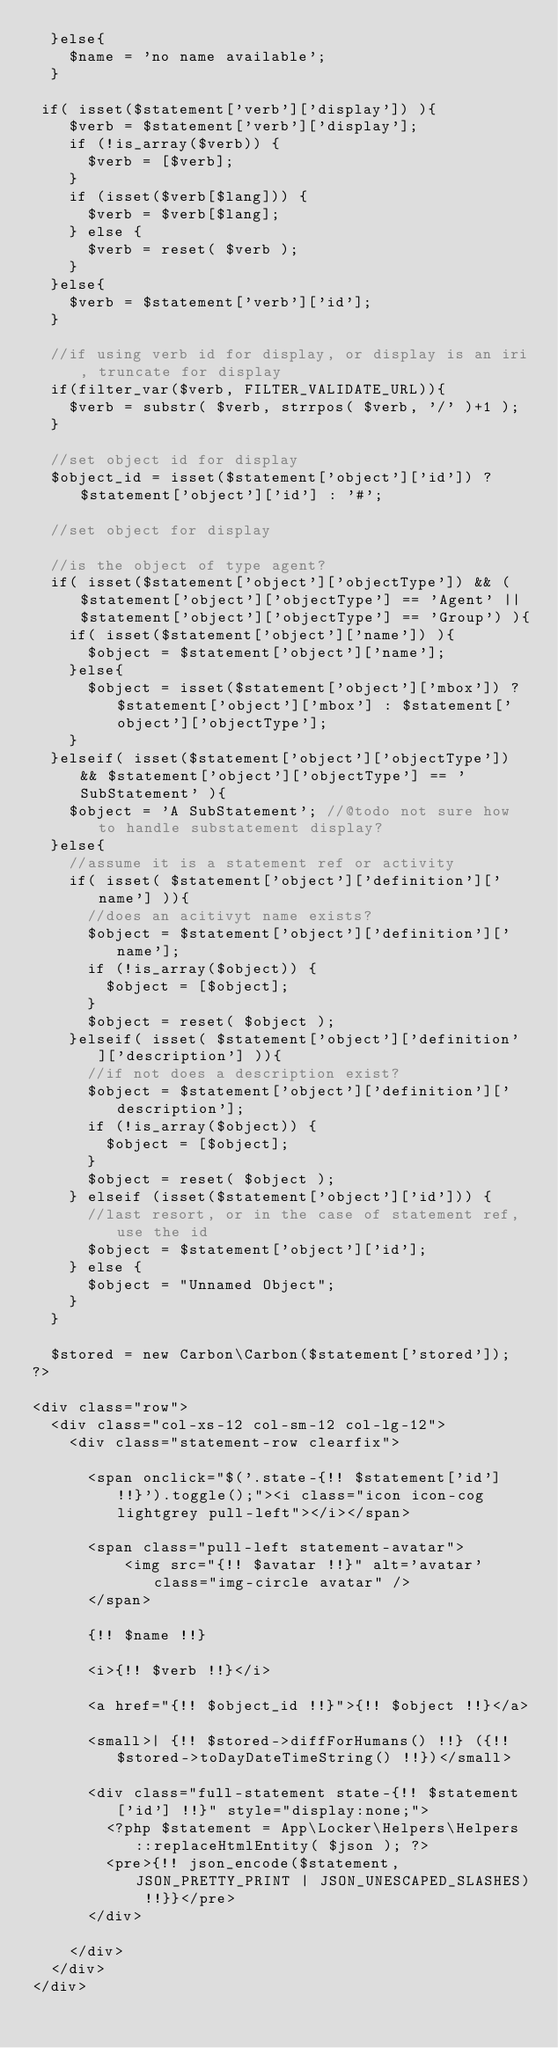Convert code to text. <code><loc_0><loc_0><loc_500><loc_500><_PHP_>  }else{
    $name = 'no name available';
  }

 if( isset($statement['verb']['display']) ){
    $verb = $statement['verb']['display'];
    if (!is_array($verb)) {
      $verb = [$verb];
    }
    if (isset($verb[$lang])) {
      $verb = $verb[$lang];
    } else {
      $verb = reset( $verb );
    }
  }else{
    $verb = $statement['verb']['id'];
  }

  //if using verb id for display, or display is an iri, truncate for display
  if(filter_var($verb, FILTER_VALIDATE_URL)){
    $verb = substr( $verb, strrpos( $verb, '/' )+1 );
  }

  //set object id for display
  $object_id = isset($statement['object']['id']) ? $statement['object']['id'] : '#';

  //set object for display

  //is the object of type agent?
  if( isset($statement['object']['objectType']) && ($statement['object']['objectType'] == 'Agent' || $statement['object']['objectType'] == 'Group') ){
    if( isset($statement['object']['name']) ){
      $object = $statement['object']['name'];
    }else{
      $object = isset($statement['object']['mbox']) ? $statement['object']['mbox'] : $statement['object']['objectType'];
    }
  }elseif( isset($statement['object']['objectType']) && $statement['object']['objectType'] == 'SubStatement' ){
    $object = 'A SubStatement'; //@todo not sure how to handle substatement display?
  }else{
    //assume it is a statement ref or activity
    if( isset( $statement['object']['definition']['name'] )){
      //does an acitivyt name exists?
      $object = $statement['object']['definition']['name'];
      if (!is_array($object)) {
        $object = [$object];
      }
      $object = reset( $object );
    }elseif( isset( $statement['object']['definition']['description'] )){
      //if not does a description exist?
      $object = $statement['object']['definition']['description'];
      if (!is_array($object)) {
        $object = [$object];
      }
      $object = reset( $object );
    } elseif (isset($statement['object']['id'])) {
      //last resort, or in the case of statement ref, use the id
      $object = $statement['object']['id'];
    } else {
      $object = "Unnamed Object";
    }
  }

  $stored = new Carbon\Carbon($statement['stored']);
?>

<div class="row">
  <div class="col-xs-12 col-sm-12 col-lg-12">
    <div class="statement-row clearfix">

      <span onclick="$('.state-{!! $statement['id'] !!}').toggle();"><i class="icon icon-cog lightgrey pull-left"></i></span>

      <span class="pull-left statement-avatar">
          <img src="{!! $avatar !!}" alt='avatar' class="img-circle avatar" />
      </span> 
        
      {!! $name !!}
      
      <i>{!! $verb !!}</i>
        
      <a href="{!! $object_id !!}">{!! $object !!}</a>

      <small>| {!! $stored->diffForHumans() !!} ({!! $stored->toDayDateTimeString() !!})</small>

      <div class="full-statement state-{!! $statement['id'] !!}" style="display:none;">
        <?php $statement = App\Locker\Helpers\Helpers::replaceHtmlEntity( $json ); ?>
        <pre>{!! json_encode($statement,JSON_PRETTY_PRINT | JSON_UNESCAPED_SLASHES) !!}}</pre>
      </div>

    </div>
  </div>
</div>
</code> 